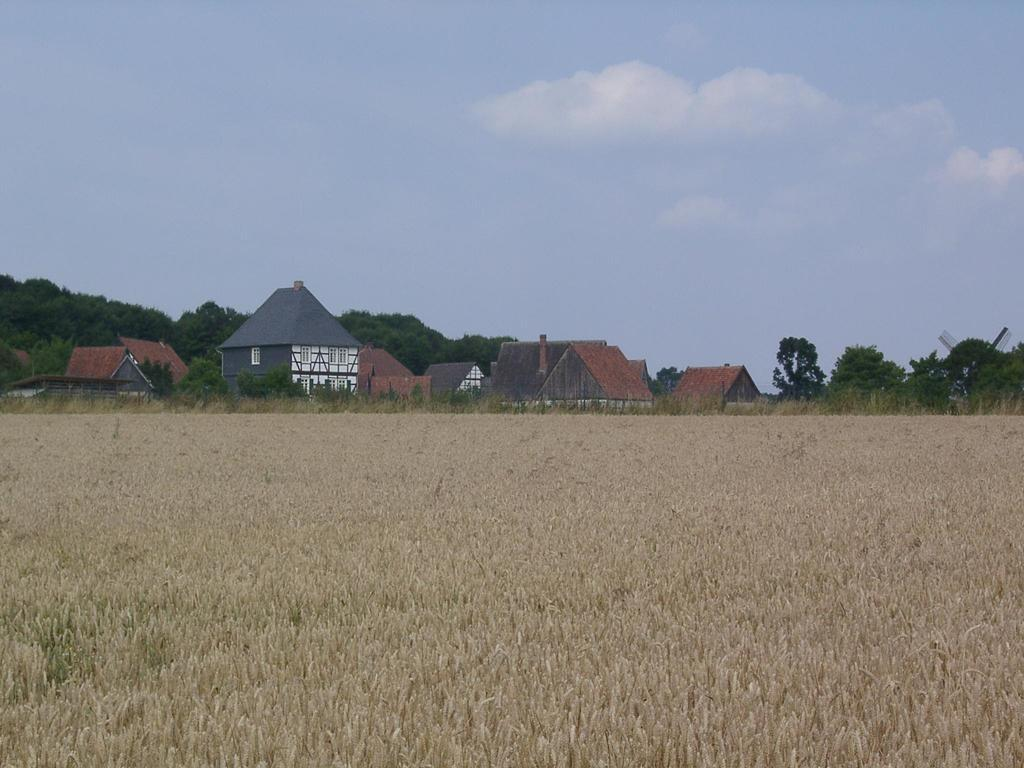Where was the image taken? The image was clicked outside the city. What can be seen in the foreground of the image? There are crops in the foreground of the image. What is visible in the background of the image? There is a sky, houses, and trees visible in the background of the image. Who is the aunt attending the feast in the image? There is no aunt or feast present in the image. What type of stitch is being used to sew the clothes in the image? There is no sewing or clothes present in the image. 